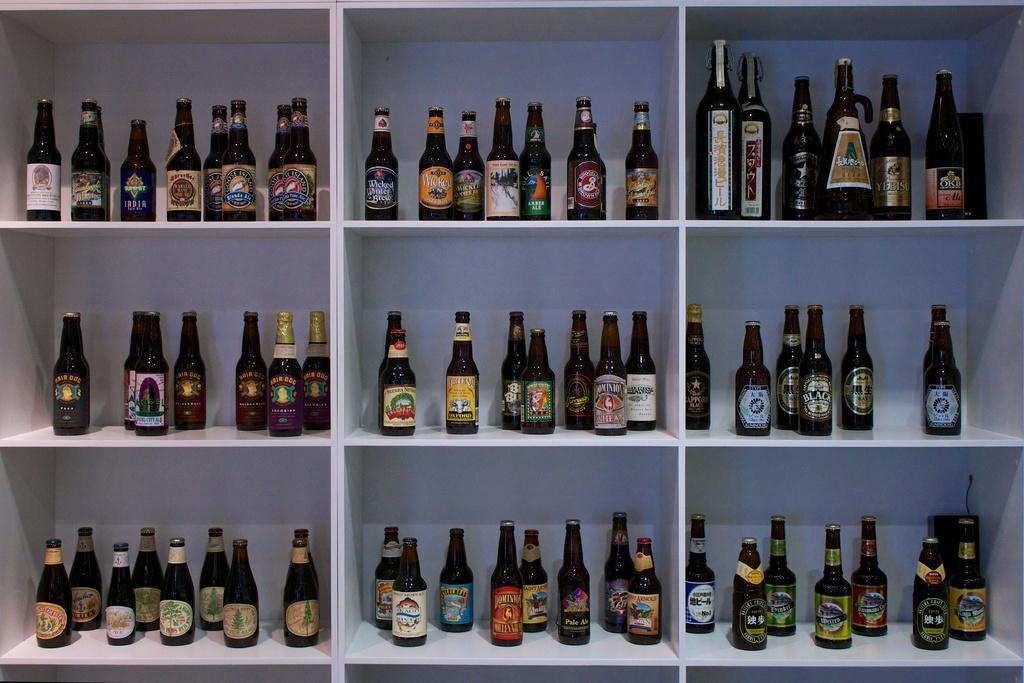How would you summarize this image in a sentence or two? In this image I can see number of bottles on these shelves. 